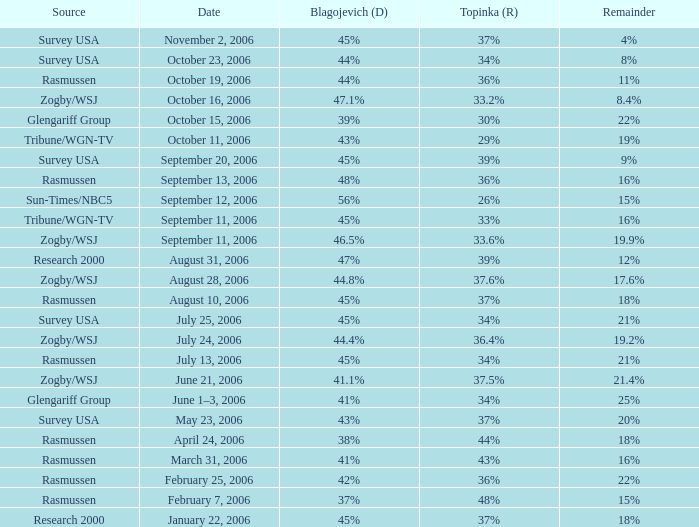Which topinka event occurred on january 22, 2006? 37%. 